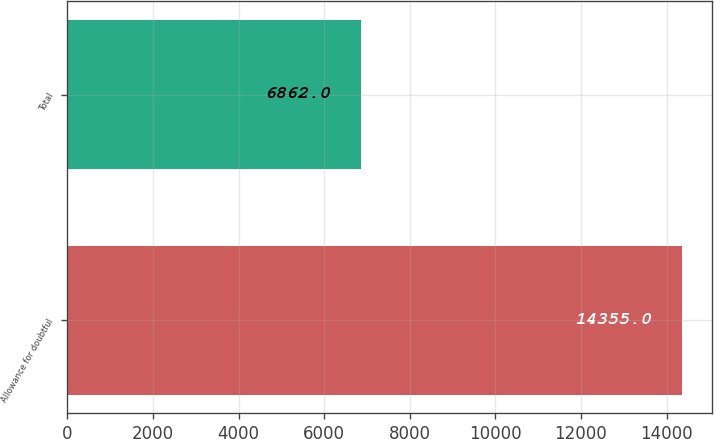Convert chart. <chart><loc_0><loc_0><loc_500><loc_500><bar_chart><fcel>Allowance for doubtful<fcel>Total<nl><fcel>14355<fcel>6862<nl></chart> 